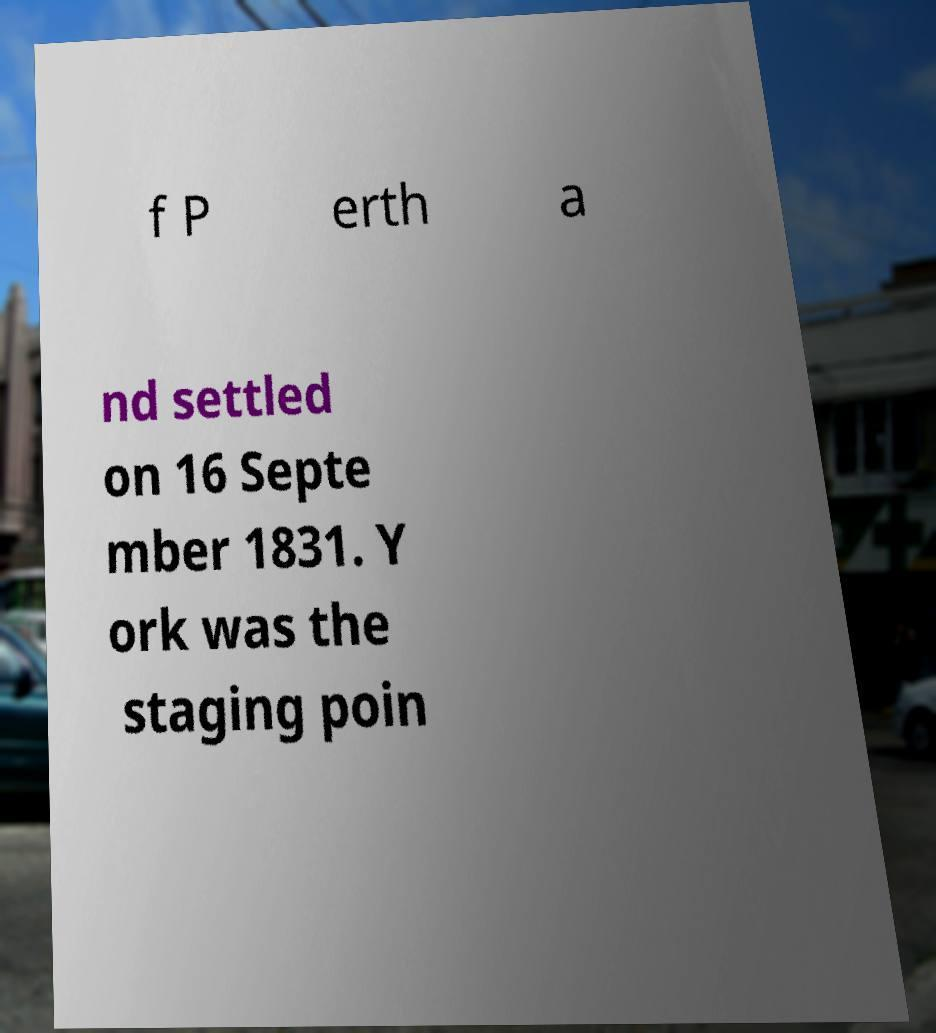Can you accurately transcribe the text from the provided image for me? f P erth a nd settled on 16 Septe mber 1831. Y ork was the staging poin 